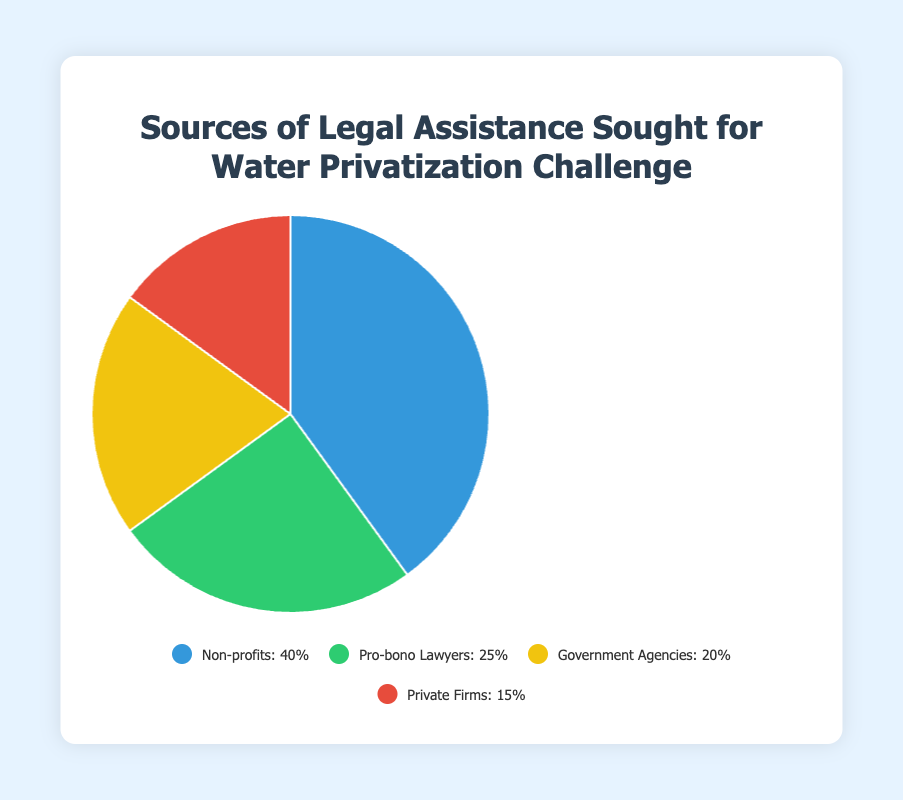Which source of legal assistance is sought the most? The pie chart shows that "Non-profits" have the largest percentage at 40%.
Answer: Non-profits Which source of legal assistance is sought the least? The pie chart indicates that "Private Firms" have the smallest percentage at 15%.
Answer: Private Firms What is the combined percentage of Government Agencies and Private Firms? Adding the percentages from the chart: 20% (Government Agencies) + 15% (Private Firms) = 35%.
Answer: 35% How much larger is the percentage of Non-profits compared to Pro-bono Lawyers? The chart shows Non-profits at 40% and Pro-bono Lawyers at 25%. The difference is 40% - 25% = 15%.
Answer: 15% If you combine Pro-bono Lawyers and Government Agencies, do they form the majority compared to Non-profits alone? First, sum the percentages for Pro-bono Lawyers and Government Agencies: 25% + 20% = 45%. Since 45% is larger than Non-profits at 40%, they form the majority.
Answer: Yes What color represents the Government Agencies section in the chart? The color corresponding to the Government Agencies section is yellow, based on the legend.
Answer: Yellow Are there more organizations sought for Pro-bono Lawyers or Private Firms? The chart shows Pro-bono Lawyers at 25% and Private Firms at 15%, so Pro-bono Lawyers have a higher percentage.
Answer: Pro-bono Lawyers Which two sources of legal assistance have the closest percentage values? Comparing the percentages: Pro-bono Lawyers at 25% and Government Agencies at 20% are the closest, with a difference of 5%.
Answer: Pro-bono Lawyers and Government Agencies What is the average percentage of all four sources of legal assistance sought? Sum the percentages: 40% (Non-profits) + 25% (Pro-bono Lawyers) + 20% (Government Agencies) + 15% (Private Firms) = 100%. The average is 100% / 4 = 25%.
Answer: 25% Which source of legal assistance is represented by the blue section in the pie chart? The blue section, according to the legend, represents "Non-profits" at 40%.
Answer: Non-profits 